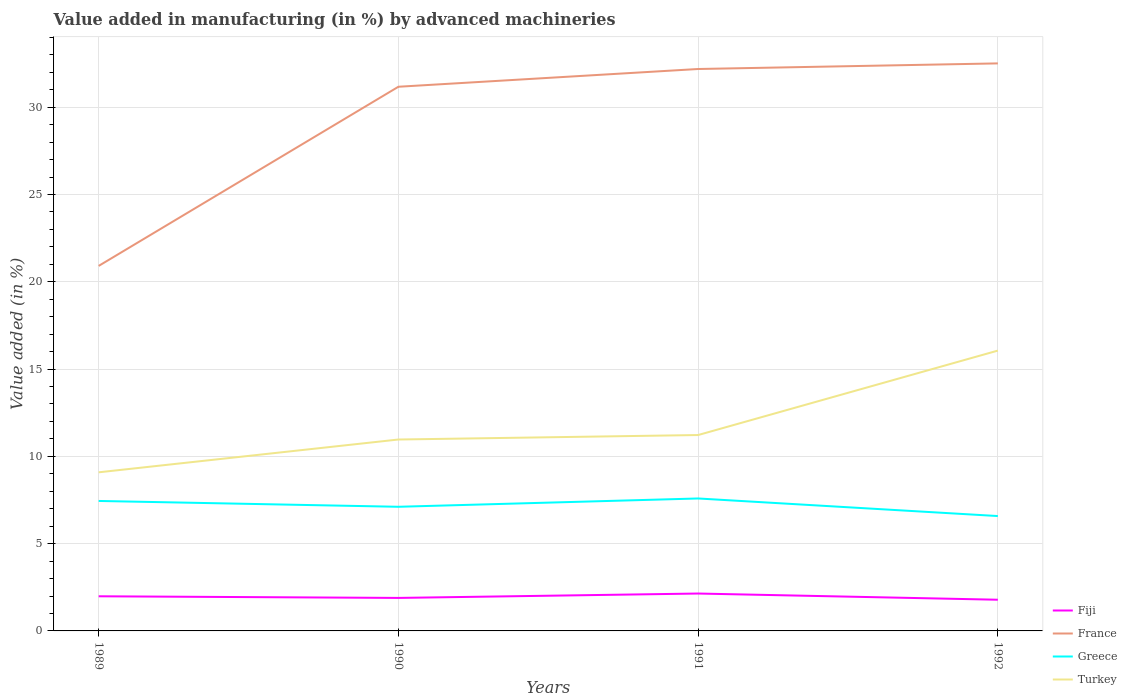Is the number of lines equal to the number of legend labels?
Provide a short and direct response. Yes. Across all years, what is the maximum percentage of value added in manufacturing by advanced machineries in Turkey?
Offer a very short reply. 9.09. In which year was the percentage of value added in manufacturing by advanced machineries in France maximum?
Provide a succinct answer. 1989. What is the total percentage of value added in manufacturing by advanced machineries in France in the graph?
Offer a terse response. -1.34. What is the difference between the highest and the second highest percentage of value added in manufacturing by advanced machineries in Greece?
Ensure brevity in your answer.  1.01. How many lines are there?
Your response must be concise. 4. What is the difference between two consecutive major ticks on the Y-axis?
Give a very brief answer. 5. Does the graph contain any zero values?
Give a very brief answer. No. Where does the legend appear in the graph?
Offer a terse response. Bottom right. How many legend labels are there?
Ensure brevity in your answer.  4. How are the legend labels stacked?
Offer a terse response. Vertical. What is the title of the graph?
Your answer should be very brief. Value added in manufacturing (in %) by advanced machineries. What is the label or title of the X-axis?
Your response must be concise. Years. What is the label or title of the Y-axis?
Your response must be concise. Value added (in %). What is the Value added (in %) in Fiji in 1989?
Give a very brief answer. 1.98. What is the Value added (in %) of France in 1989?
Your response must be concise. 20.91. What is the Value added (in %) in Greece in 1989?
Your response must be concise. 7.45. What is the Value added (in %) in Turkey in 1989?
Offer a very short reply. 9.09. What is the Value added (in %) of Fiji in 1990?
Give a very brief answer. 1.89. What is the Value added (in %) in France in 1990?
Offer a very short reply. 31.17. What is the Value added (in %) in Greece in 1990?
Offer a terse response. 7.11. What is the Value added (in %) of Turkey in 1990?
Give a very brief answer. 10.97. What is the Value added (in %) in Fiji in 1991?
Make the answer very short. 2.14. What is the Value added (in %) in France in 1991?
Your answer should be very brief. 32.19. What is the Value added (in %) in Greece in 1991?
Your response must be concise. 7.59. What is the Value added (in %) of Turkey in 1991?
Provide a succinct answer. 11.22. What is the Value added (in %) of Fiji in 1992?
Provide a short and direct response. 1.79. What is the Value added (in %) in France in 1992?
Your answer should be very brief. 32.51. What is the Value added (in %) in Greece in 1992?
Your answer should be very brief. 6.58. What is the Value added (in %) in Turkey in 1992?
Keep it short and to the point. 16.06. Across all years, what is the maximum Value added (in %) of Fiji?
Provide a succinct answer. 2.14. Across all years, what is the maximum Value added (in %) of France?
Your response must be concise. 32.51. Across all years, what is the maximum Value added (in %) of Greece?
Give a very brief answer. 7.59. Across all years, what is the maximum Value added (in %) of Turkey?
Give a very brief answer. 16.06. Across all years, what is the minimum Value added (in %) of Fiji?
Give a very brief answer. 1.79. Across all years, what is the minimum Value added (in %) in France?
Make the answer very short. 20.91. Across all years, what is the minimum Value added (in %) of Greece?
Give a very brief answer. 6.58. Across all years, what is the minimum Value added (in %) in Turkey?
Give a very brief answer. 9.09. What is the total Value added (in %) in Fiji in the graph?
Keep it short and to the point. 7.8. What is the total Value added (in %) of France in the graph?
Provide a succinct answer. 116.79. What is the total Value added (in %) of Greece in the graph?
Keep it short and to the point. 28.73. What is the total Value added (in %) of Turkey in the graph?
Offer a very short reply. 47.33. What is the difference between the Value added (in %) in Fiji in 1989 and that in 1990?
Offer a terse response. 0.09. What is the difference between the Value added (in %) of France in 1989 and that in 1990?
Offer a terse response. -10.26. What is the difference between the Value added (in %) in Greece in 1989 and that in 1990?
Provide a succinct answer. 0.33. What is the difference between the Value added (in %) in Turkey in 1989 and that in 1990?
Your answer should be very brief. -1.88. What is the difference between the Value added (in %) of Fiji in 1989 and that in 1991?
Ensure brevity in your answer.  -0.16. What is the difference between the Value added (in %) in France in 1989 and that in 1991?
Your response must be concise. -11.28. What is the difference between the Value added (in %) in Greece in 1989 and that in 1991?
Your answer should be compact. -0.14. What is the difference between the Value added (in %) in Turkey in 1989 and that in 1991?
Offer a very short reply. -2.14. What is the difference between the Value added (in %) of Fiji in 1989 and that in 1992?
Provide a short and direct response. 0.2. What is the difference between the Value added (in %) in France in 1989 and that in 1992?
Give a very brief answer. -11.6. What is the difference between the Value added (in %) of Greece in 1989 and that in 1992?
Keep it short and to the point. 0.86. What is the difference between the Value added (in %) of Turkey in 1989 and that in 1992?
Offer a terse response. -6.97. What is the difference between the Value added (in %) of Fiji in 1990 and that in 1991?
Make the answer very short. -0.25. What is the difference between the Value added (in %) in France in 1990 and that in 1991?
Keep it short and to the point. -1.02. What is the difference between the Value added (in %) of Greece in 1990 and that in 1991?
Ensure brevity in your answer.  -0.48. What is the difference between the Value added (in %) of Turkey in 1990 and that in 1991?
Ensure brevity in your answer.  -0.26. What is the difference between the Value added (in %) in Fiji in 1990 and that in 1992?
Keep it short and to the point. 0.1. What is the difference between the Value added (in %) of France in 1990 and that in 1992?
Your response must be concise. -1.34. What is the difference between the Value added (in %) of Greece in 1990 and that in 1992?
Provide a short and direct response. 0.53. What is the difference between the Value added (in %) in Turkey in 1990 and that in 1992?
Offer a very short reply. -5.09. What is the difference between the Value added (in %) of Fiji in 1991 and that in 1992?
Keep it short and to the point. 0.36. What is the difference between the Value added (in %) in France in 1991 and that in 1992?
Your answer should be compact. -0.32. What is the difference between the Value added (in %) in Greece in 1991 and that in 1992?
Your answer should be very brief. 1.01. What is the difference between the Value added (in %) in Turkey in 1991 and that in 1992?
Keep it short and to the point. -4.84. What is the difference between the Value added (in %) of Fiji in 1989 and the Value added (in %) of France in 1990?
Your answer should be compact. -29.19. What is the difference between the Value added (in %) in Fiji in 1989 and the Value added (in %) in Greece in 1990?
Provide a short and direct response. -5.13. What is the difference between the Value added (in %) of Fiji in 1989 and the Value added (in %) of Turkey in 1990?
Your answer should be very brief. -8.98. What is the difference between the Value added (in %) of France in 1989 and the Value added (in %) of Greece in 1990?
Provide a short and direct response. 13.8. What is the difference between the Value added (in %) of France in 1989 and the Value added (in %) of Turkey in 1990?
Your answer should be very brief. 9.95. What is the difference between the Value added (in %) of Greece in 1989 and the Value added (in %) of Turkey in 1990?
Give a very brief answer. -3.52. What is the difference between the Value added (in %) in Fiji in 1989 and the Value added (in %) in France in 1991?
Make the answer very short. -30.21. What is the difference between the Value added (in %) of Fiji in 1989 and the Value added (in %) of Greece in 1991?
Keep it short and to the point. -5.6. What is the difference between the Value added (in %) in Fiji in 1989 and the Value added (in %) in Turkey in 1991?
Your response must be concise. -9.24. What is the difference between the Value added (in %) of France in 1989 and the Value added (in %) of Greece in 1991?
Provide a succinct answer. 13.32. What is the difference between the Value added (in %) of France in 1989 and the Value added (in %) of Turkey in 1991?
Your answer should be very brief. 9.69. What is the difference between the Value added (in %) of Greece in 1989 and the Value added (in %) of Turkey in 1991?
Provide a succinct answer. -3.78. What is the difference between the Value added (in %) in Fiji in 1989 and the Value added (in %) in France in 1992?
Your response must be concise. -30.53. What is the difference between the Value added (in %) in Fiji in 1989 and the Value added (in %) in Greece in 1992?
Your answer should be very brief. -4.6. What is the difference between the Value added (in %) in Fiji in 1989 and the Value added (in %) in Turkey in 1992?
Make the answer very short. -14.08. What is the difference between the Value added (in %) of France in 1989 and the Value added (in %) of Greece in 1992?
Offer a terse response. 14.33. What is the difference between the Value added (in %) in France in 1989 and the Value added (in %) in Turkey in 1992?
Offer a terse response. 4.85. What is the difference between the Value added (in %) of Greece in 1989 and the Value added (in %) of Turkey in 1992?
Ensure brevity in your answer.  -8.61. What is the difference between the Value added (in %) in Fiji in 1990 and the Value added (in %) in France in 1991?
Provide a short and direct response. -30.3. What is the difference between the Value added (in %) in Fiji in 1990 and the Value added (in %) in Greece in 1991?
Make the answer very short. -5.7. What is the difference between the Value added (in %) of Fiji in 1990 and the Value added (in %) of Turkey in 1991?
Your answer should be compact. -9.33. What is the difference between the Value added (in %) in France in 1990 and the Value added (in %) in Greece in 1991?
Offer a very short reply. 23.59. What is the difference between the Value added (in %) in France in 1990 and the Value added (in %) in Turkey in 1991?
Provide a short and direct response. 19.95. What is the difference between the Value added (in %) of Greece in 1990 and the Value added (in %) of Turkey in 1991?
Provide a succinct answer. -4.11. What is the difference between the Value added (in %) of Fiji in 1990 and the Value added (in %) of France in 1992?
Your response must be concise. -30.62. What is the difference between the Value added (in %) in Fiji in 1990 and the Value added (in %) in Greece in 1992?
Offer a terse response. -4.69. What is the difference between the Value added (in %) of Fiji in 1990 and the Value added (in %) of Turkey in 1992?
Provide a succinct answer. -14.17. What is the difference between the Value added (in %) in France in 1990 and the Value added (in %) in Greece in 1992?
Make the answer very short. 24.59. What is the difference between the Value added (in %) in France in 1990 and the Value added (in %) in Turkey in 1992?
Offer a terse response. 15.11. What is the difference between the Value added (in %) of Greece in 1990 and the Value added (in %) of Turkey in 1992?
Your answer should be very brief. -8.95. What is the difference between the Value added (in %) of Fiji in 1991 and the Value added (in %) of France in 1992?
Give a very brief answer. -30.37. What is the difference between the Value added (in %) in Fiji in 1991 and the Value added (in %) in Greece in 1992?
Provide a short and direct response. -4.44. What is the difference between the Value added (in %) in Fiji in 1991 and the Value added (in %) in Turkey in 1992?
Your answer should be very brief. -13.92. What is the difference between the Value added (in %) of France in 1991 and the Value added (in %) of Greece in 1992?
Offer a very short reply. 25.61. What is the difference between the Value added (in %) in France in 1991 and the Value added (in %) in Turkey in 1992?
Offer a terse response. 16.13. What is the difference between the Value added (in %) in Greece in 1991 and the Value added (in %) in Turkey in 1992?
Keep it short and to the point. -8.47. What is the average Value added (in %) of Fiji per year?
Provide a succinct answer. 1.95. What is the average Value added (in %) in France per year?
Ensure brevity in your answer.  29.2. What is the average Value added (in %) of Greece per year?
Make the answer very short. 7.18. What is the average Value added (in %) in Turkey per year?
Provide a short and direct response. 11.83. In the year 1989, what is the difference between the Value added (in %) of Fiji and Value added (in %) of France?
Make the answer very short. -18.93. In the year 1989, what is the difference between the Value added (in %) in Fiji and Value added (in %) in Greece?
Make the answer very short. -5.46. In the year 1989, what is the difference between the Value added (in %) of Fiji and Value added (in %) of Turkey?
Provide a succinct answer. -7.1. In the year 1989, what is the difference between the Value added (in %) in France and Value added (in %) in Greece?
Ensure brevity in your answer.  13.47. In the year 1989, what is the difference between the Value added (in %) in France and Value added (in %) in Turkey?
Provide a short and direct response. 11.82. In the year 1989, what is the difference between the Value added (in %) of Greece and Value added (in %) of Turkey?
Your response must be concise. -1.64. In the year 1990, what is the difference between the Value added (in %) of Fiji and Value added (in %) of France?
Provide a short and direct response. -29.28. In the year 1990, what is the difference between the Value added (in %) of Fiji and Value added (in %) of Greece?
Offer a terse response. -5.22. In the year 1990, what is the difference between the Value added (in %) in Fiji and Value added (in %) in Turkey?
Provide a short and direct response. -9.07. In the year 1990, what is the difference between the Value added (in %) of France and Value added (in %) of Greece?
Your response must be concise. 24.06. In the year 1990, what is the difference between the Value added (in %) in France and Value added (in %) in Turkey?
Your response must be concise. 20.21. In the year 1990, what is the difference between the Value added (in %) in Greece and Value added (in %) in Turkey?
Provide a succinct answer. -3.85. In the year 1991, what is the difference between the Value added (in %) in Fiji and Value added (in %) in France?
Keep it short and to the point. -30.05. In the year 1991, what is the difference between the Value added (in %) of Fiji and Value added (in %) of Greece?
Provide a succinct answer. -5.45. In the year 1991, what is the difference between the Value added (in %) in Fiji and Value added (in %) in Turkey?
Your response must be concise. -9.08. In the year 1991, what is the difference between the Value added (in %) in France and Value added (in %) in Greece?
Your answer should be very brief. 24.6. In the year 1991, what is the difference between the Value added (in %) in France and Value added (in %) in Turkey?
Your answer should be compact. 20.97. In the year 1991, what is the difference between the Value added (in %) in Greece and Value added (in %) in Turkey?
Your answer should be very brief. -3.63. In the year 1992, what is the difference between the Value added (in %) in Fiji and Value added (in %) in France?
Provide a succinct answer. -30.73. In the year 1992, what is the difference between the Value added (in %) in Fiji and Value added (in %) in Greece?
Provide a short and direct response. -4.79. In the year 1992, what is the difference between the Value added (in %) in Fiji and Value added (in %) in Turkey?
Provide a short and direct response. -14.27. In the year 1992, what is the difference between the Value added (in %) of France and Value added (in %) of Greece?
Keep it short and to the point. 25.93. In the year 1992, what is the difference between the Value added (in %) in France and Value added (in %) in Turkey?
Provide a succinct answer. 16.45. In the year 1992, what is the difference between the Value added (in %) in Greece and Value added (in %) in Turkey?
Your answer should be compact. -9.48. What is the ratio of the Value added (in %) in Fiji in 1989 to that in 1990?
Offer a very short reply. 1.05. What is the ratio of the Value added (in %) of France in 1989 to that in 1990?
Your answer should be compact. 0.67. What is the ratio of the Value added (in %) of Greece in 1989 to that in 1990?
Your response must be concise. 1.05. What is the ratio of the Value added (in %) in Turkey in 1989 to that in 1990?
Offer a very short reply. 0.83. What is the ratio of the Value added (in %) in Fiji in 1989 to that in 1991?
Keep it short and to the point. 0.93. What is the ratio of the Value added (in %) of France in 1989 to that in 1991?
Give a very brief answer. 0.65. What is the ratio of the Value added (in %) of Greece in 1989 to that in 1991?
Offer a very short reply. 0.98. What is the ratio of the Value added (in %) in Turkey in 1989 to that in 1991?
Offer a terse response. 0.81. What is the ratio of the Value added (in %) in Fiji in 1989 to that in 1992?
Offer a very short reply. 1.11. What is the ratio of the Value added (in %) in France in 1989 to that in 1992?
Your response must be concise. 0.64. What is the ratio of the Value added (in %) in Greece in 1989 to that in 1992?
Provide a succinct answer. 1.13. What is the ratio of the Value added (in %) of Turkey in 1989 to that in 1992?
Your answer should be compact. 0.57. What is the ratio of the Value added (in %) of Fiji in 1990 to that in 1991?
Provide a succinct answer. 0.88. What is the ratio of the Value added (in %) of France in 1990 to that in 1991?
Provide a succinct answer. 0.97. What is the ratio of the Value added (in %) in Greece in 1990 to that in 1991?
Provide a short and direct response. 0.94. What is the ratio of the Value added (in %) of Turkey in 1990 to that in 1991?
Your response must be concise. 0.98. What is the ratio of the Value added (in %) of Fiji in 1990 to that in 1992?
Ensure brevity in your answer.  1.06. What is the ratio of the Value added (in %) in France in 1990 to that in 1992?
Your answer should be compact. 0.96. What is the ratio of the Value added (in %) in Greece in 1990 to that in 1992?
Your answer should be very brief. 1.08. What is the ratio of the Value added (in %) of Turkey in 1990 to that in 1992?
Ensure brevity in your answer.  0.68. What is the ratio of the Value added (in %) in Fiji in 1991 to that in 1992?
Provide a succinct answer. 1.2. What is the ratio of the Value added (in %) of France in 1991 to that in 1992?
Your response must be concise. 0.99. What is the ratio of the Value added (in %) of Greece in 1991 to that in 1992?
Ensure brevity in your answer.  1.15. What is the ratio of the Value added (in %) of Turkey in 1991 to that in 1992?
Your response must be concise. 0.7. What is the difference between the highest and the second highest Value added (in %) in Fiji?
Offer a terse response. 0.16. What is the difference between the highest and the second highest Value added (in %) in France?
Provide a short and direct response. 0.32. What is the difference between the highest and the second highest Value added (in %) of Greece?
Offer a very short reply. 0.14. What is the difference between the highest and the second highest Value added (in %) of Turkey?
Provide a short and direct response. 4.84. What is the difference between the highest and the lowest Value added (in %) in Fiji?
Your answer should be compact. 0.36. What is the difference between the highest and the lowest Value added (in %) of France?
Provide a short and direct response. 11.6. What is the difference between the highest and the lowest Value added (in %) in Greece?
Your response must be concise. 1.01. What is the difference between the highest and the lowest Value added (in %) in Turkey?
Your answer should be very brief. 6.97. 